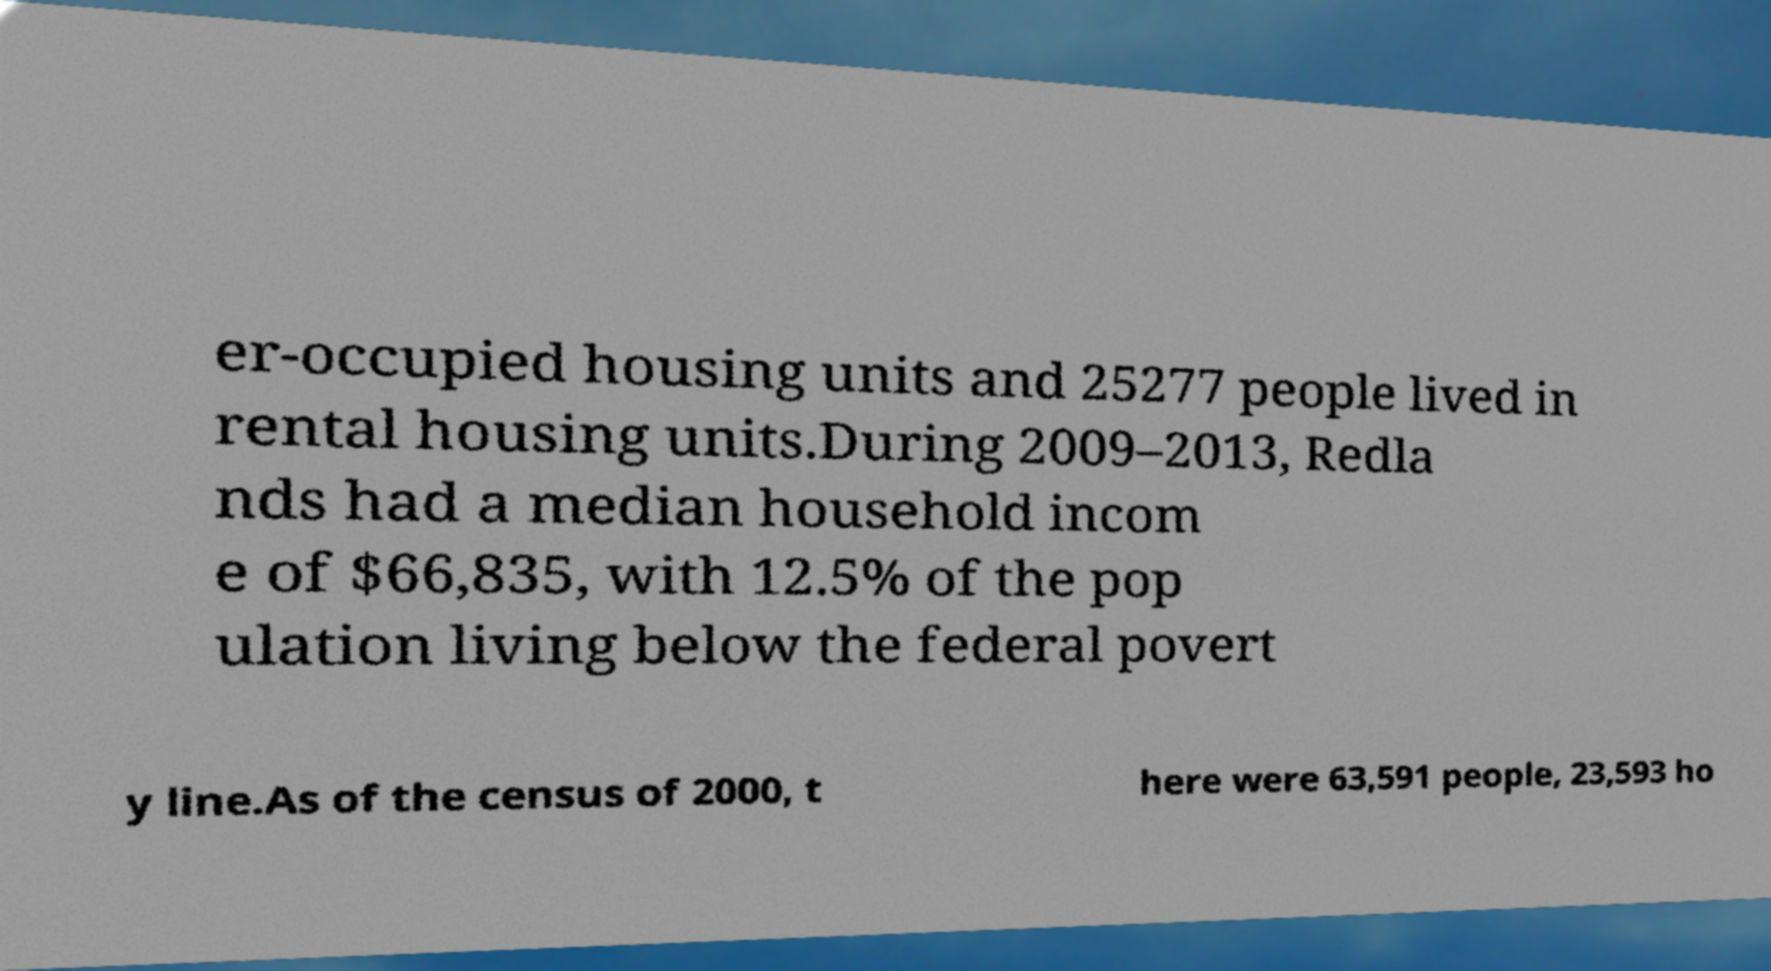What messages or text are displayed in this image? I need them in a readable, typed format. er-occupied housing units and 25277 people lived in rental housing units.During 2009–2013, Redla nds had a median household incom e of $66,835, with 12.5% of the pop ulation living below the federal povert y line.As of the census of 2000, t here were 63,591 people, 23,593 ho 